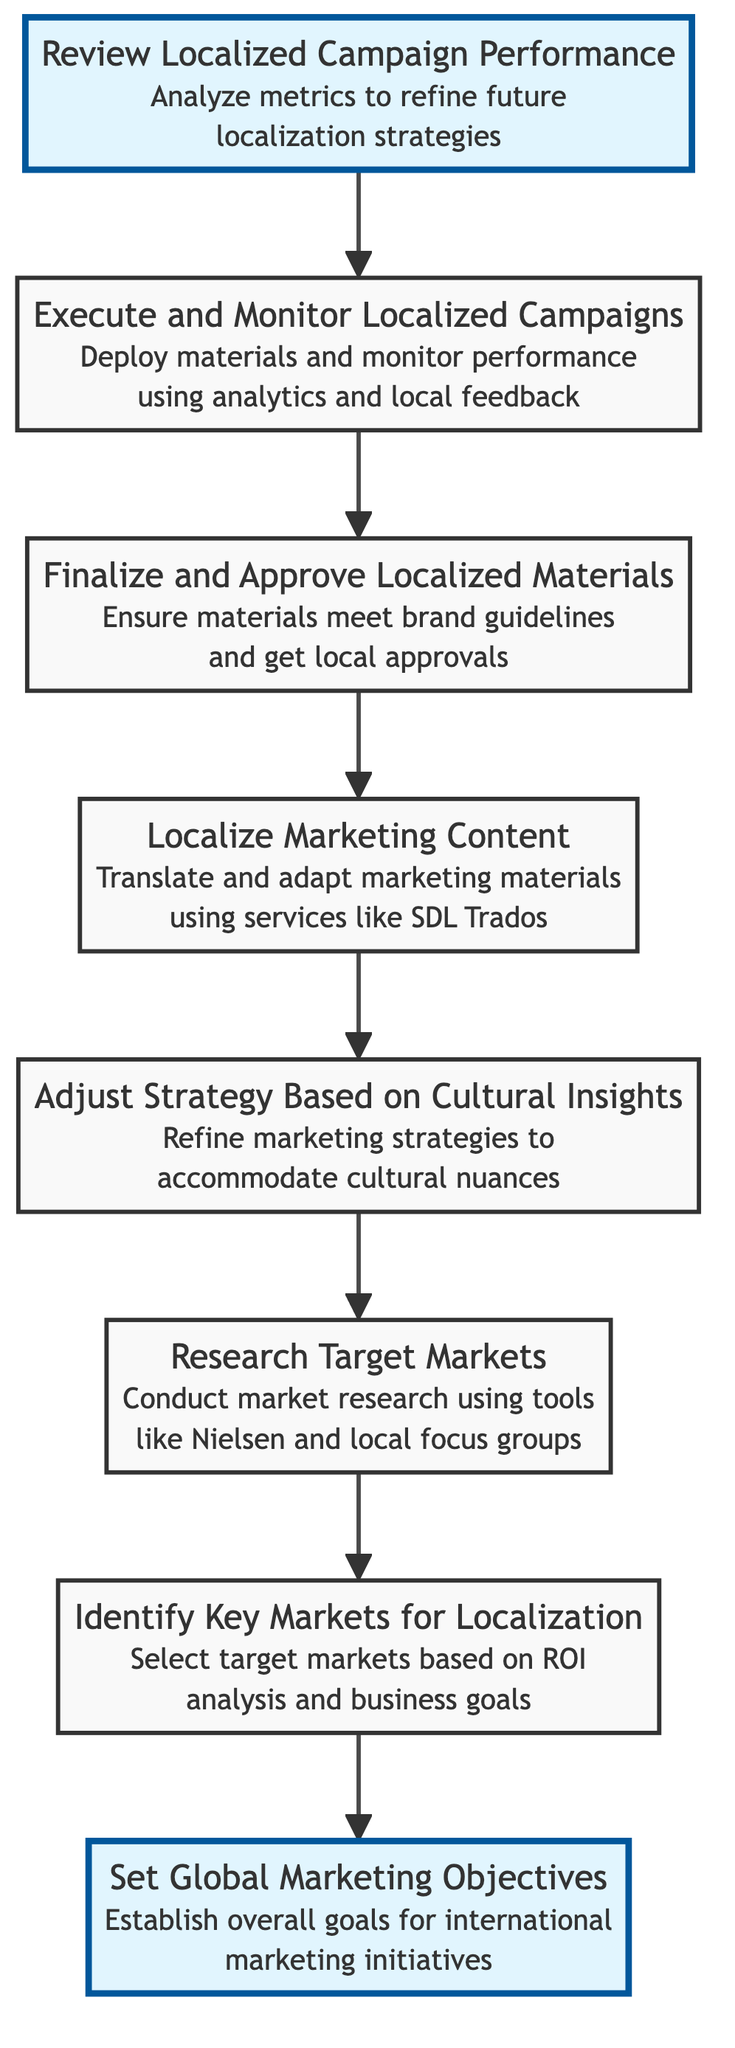What is the first step in the workflow? The diagram starts with "Set Global Marketing Objectives" at the bottom of the flowchart, indicating this is the initial action in the workflow process.
Answer: Set Global Marketing Objectives How many total nodes are in the diagram? The diagram shows 8 nodes, each representing a distinct step in the workflow process for adapting marketing strategies across different cultures.
Answer: 8 What step comes immediately after "Finalize and Approve Localized Materials"? In the flowchart, the arrow from "Finalize and Approve Localized Materials" points to "Localize Marketing Content," indicating that this is the next step in the process.
Answer: Localize Marketing Content Which step involves conducting market research? "Research Target Markets" is the step that specifically mentions conducting market research using appropriate tools to understand cultural preferences.
Answer: Research Target Markets What is the last step in the workflow? The last step in the workflow is "Review Localized Campaign Performance," which indicates that performance is assessed after the localized campaigns have been executed.
Answer: Review Localized Campaign Performance What step is focused on cultural insights adjustment? The step titled "Adjust Strategy Based on Cultural Insights" relates directly to refining marketing strategies to align with cultural nuances identified in previous research stages.
Answer: Adjust Strategy Based on Cultural Insights How many steps involve localization of marketing content? The flowchart includes two distinct steps that involve localization: "Localize Marketing Content" and "Finalize and Approve Localized Materials," both of which are integral to the localization process.
Answer: 2 What is the relationship between "Identify Key Markets for Localization" and "Set Global Marketing Objectives"? "Identify Key Markets for Localization" is the seventh step in the sequence, which logically follows the foundational step "Set Global Marketing Objectives" as it focuses on setting the direction based on the established goals.
Answer: Sequential relationship 